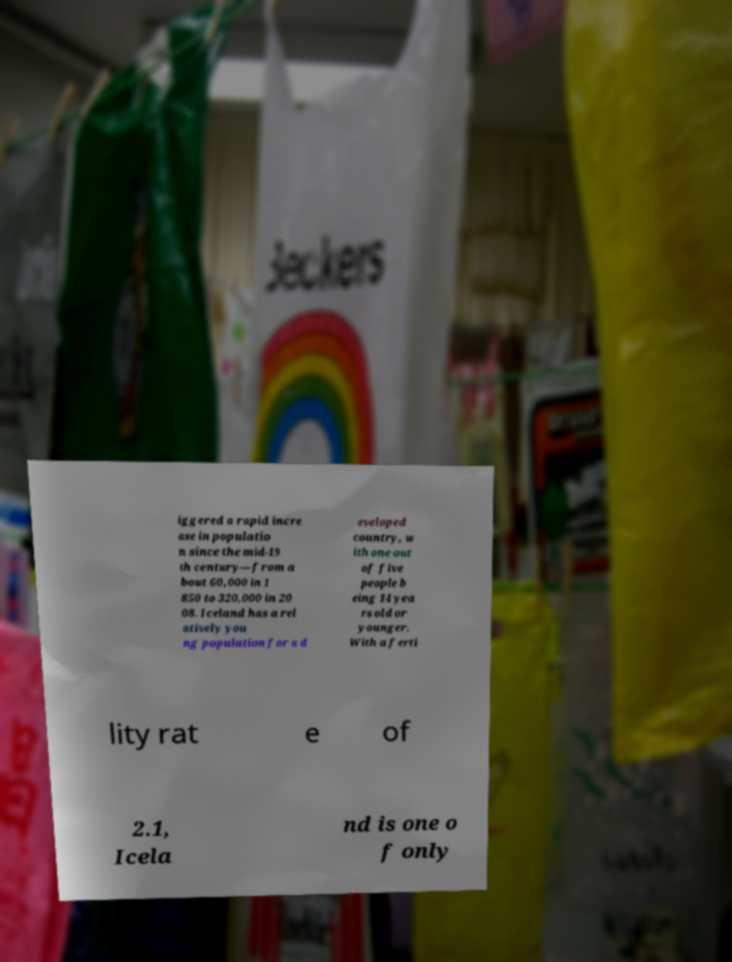Please identify and transcribe the text found in this image. iggered a rapid incre ase in populatio n since the mid-19 th century—from a bout 60,000 in 1 850 to 320,000 in 20 08. Iceland has a rel atively you ng population for a d eveloped country, w ith one out of five people b eing 14 yea rs old or younger. With a ferti lity rat e of 2.1, Icela nd is one o f only 